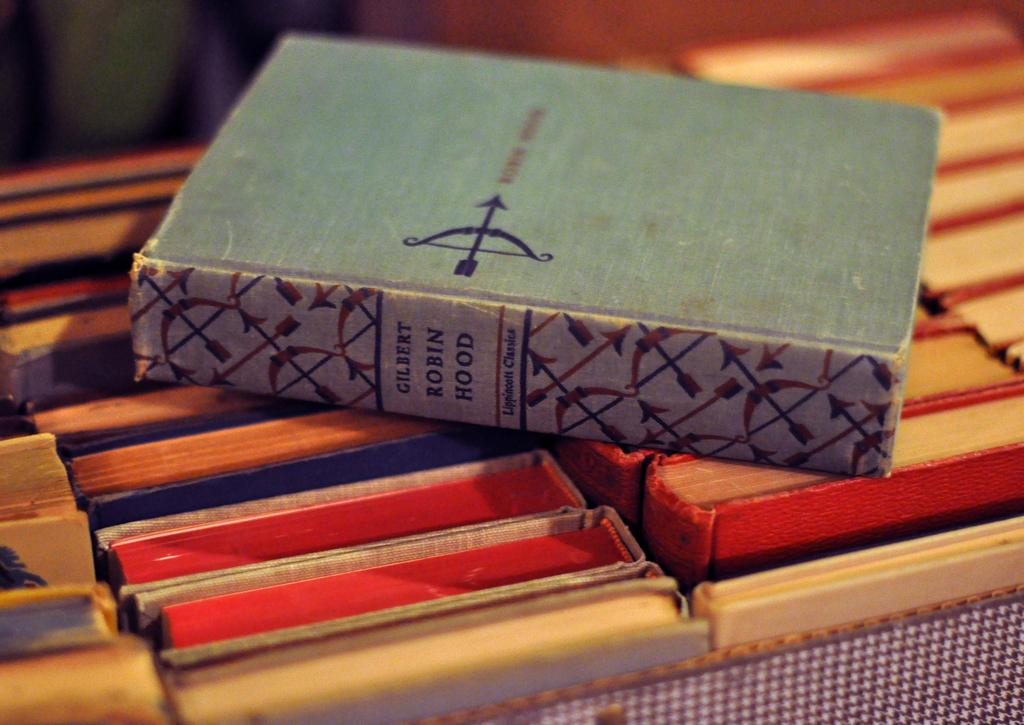<image>
Describe the image concisely. The Robin Hood novel sits above a stack of old books in a box. 